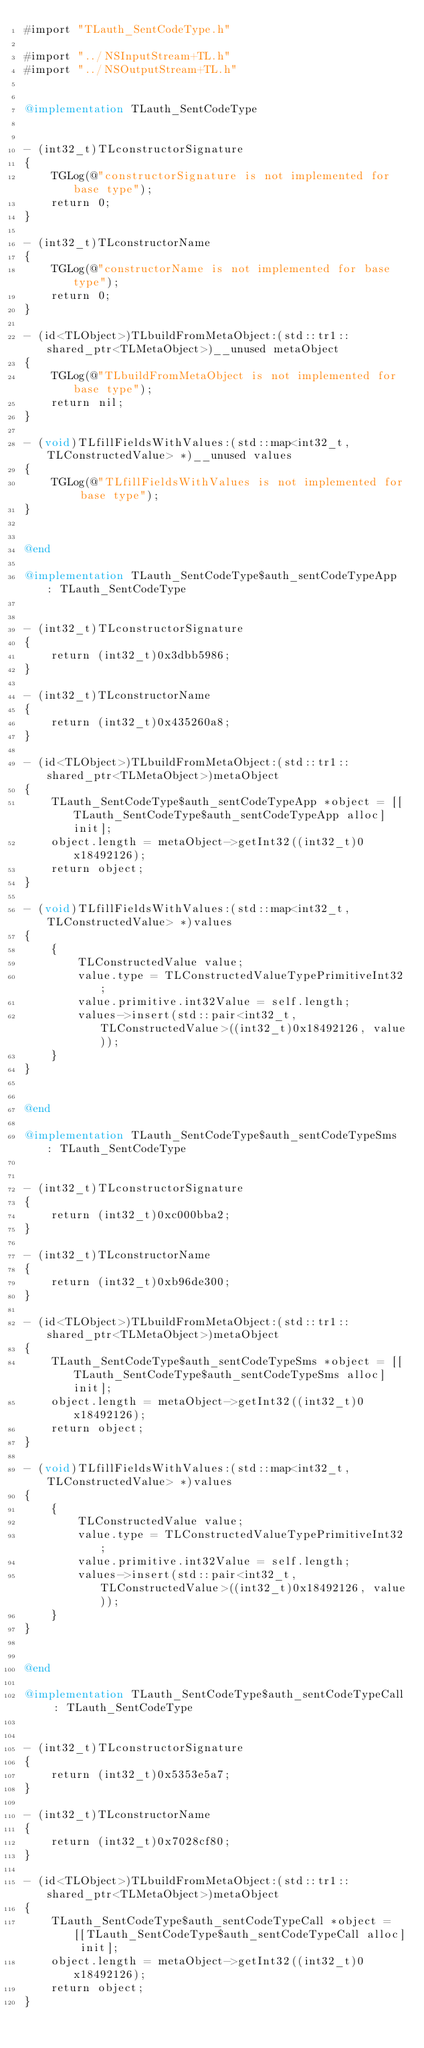Convert code to text. <code><loc_0><loc_0><loc_500><loc_500><_ObjectiveC_>#import "TLauth_SentCodeType.h"

#import "../NSInputStream+TL.h"
#import "../NSOutputStream+TL.h"


@implementation TLauth_SentCodeType


- (int32_t)TLconstructorSignature
{
    TGLog(@"constructorSignature is not implemented for base type");
    return 0;
}

- (int32_t)TLconstructorName
{
    TGLog(@"constructorName is not implemented for base type");
    return 0;
}

- (id<TLObject>)TLbuildFromMetaObject:(std::tr1::shared_ptr<TLMetaObject>)__unused metaObject
{
    TGLog(@"TLbuildFromMetaObject is not implemented for base type");
    return nil;
}

- (void)TLfillFieldsWithValues:(std::map<int32_t, TLConstructedValue> *)__unused values
{
    TGLog(@"TLfillFieldsWithValues is not implemented for base type");
}


@end

@implementation TLauth_SentCodeType$auth_sentCodeTypeApp : TLauth_SentCodeType


- (int32_t)TLconstructorSignature
{
    return (int32_t)0x3dbb5986;
}

- (int32_t)TLconstructorName
{
    return (int32_t)0x435260a8;
}

- (id<TLObject>)TLbuildFromMetaObject:(std::tr1::shared_ptr<TLMetaObject>)metaObject
{
    TLauth_SentCodeType$auth_sentCodeTypeApp *object = [[TLauth_SentCodeType$auth_sentCodeTypeApp alloc] init];
    object.length = metaObject->getInt32((int32_t)0x18492126);
    return object;
}

- (void)TLfillFieldsWithValues:(std::map<int32_t, TLConstructedValue> *)values
{
    {
        TLConstructedValue value;
        value.type = TLConstructedValueTypePrimitiveInt32;
        value.primitive.int32Value = self.length;
        values->insert(std::pair<int32_t, TLConstructedValue>((int32_t)0x18492126, value));
    }
}


@end

@implementation TLauth_SentCodeType$auth_sentCodeTypeSms : TLauth_SentCodeType


- (int32_t)TLconstructorSignature
{
    return (int32_t)0xc000bba2;
}

- (int32_t)TLconstructorName
{
    return (int32_t)0xb96de300;
}

- (id<TLObject>)TLbuildFromMetaObject:(std::tr1::shared_ptr<TLMetaObject>)metaObject
{
    TLauth_SentCodeType$auth_sentCodeTypeSms *object = [[TLauth_SentCodeType$auth_sentCodeTypeSms alloc] init];
    object.length = metaObject->getInt32((int32_t)0x18492126);
    return object;
}

- (void)TLfillFieldsWithValues:(std::map<int32_t, TLConstructedValue> *)values
{
    {
        TLConstructedValue value;
        value.type = TLConstructedValueTypePrimitiveInt32;
        value.primitive.int32Value = self.length;
        values->insert(std::pair<int32_t, TLConstructedValue>((int32_t)0x18492126, value));
    }
}


@end

@implementation TLauth_SentCodeType$auth_sentCodeTypeCall : TLauth_SentCodeType


- (int32_t)TLconstructorSignature
{
    return (int32_t)0x5353e5a7;
}

- (int32_t)TLconstructorName
{
    return (int32_t)0x7028cf80;
}

- (id<TLObject>)TLbuildFromMetaObject:(std::tr1::shared_ptr<TLMetaObject>)metaObject
{
    TLauth_SentCodeType$auth_sentCodeTypeCall *object = [[TLauth_SentCodeType$auth_sentCodeTypeCall alloc] init];
    object.length = metaObject->getInt32((int32_t)0x18492126);
    return object;
}
</code> 